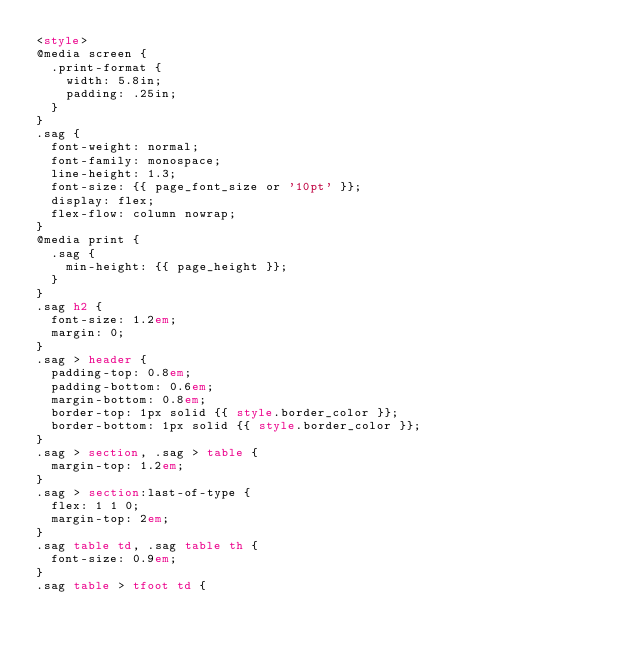<code> <loc_0><loc_0><loc_500><loc_500><_HTML_><style>
@media screen {
  .print-format {
    width: 5.8in;
    padding: .25in;
  }
}
.sag {
  font-weight: normal;
  font-family: monospace;
  line-height: 1.3;
  font-size: {{ page_font_size or '10pt' }};
  display: flex;
  flex-flow: column nowrap;
}
@media print {
  .sag {
    min-height: {{ page_height }};
  }
}
.sag h2 {
  font-size: 1.2em;
  margin: 0;
}
.sag > header {
  padding-top: 0.8em;
  padding-bottom: 0.6em;
  margin-bottom: 0.8em;
  border-top: 1px solid {{ style.border_color }};
  border-bottom: 1px solid {{ style.border_color }};
}
.sag > section, .sag > table {
  margin-top: 1.2em;
}
.sag > section:last-of-type {
  flex: 1 1 0;
  margin-top: 2em;
}
.sag table td, .sag table th {
  font-size: 0.9em;
}
.sag table > tfoot td {</code> 